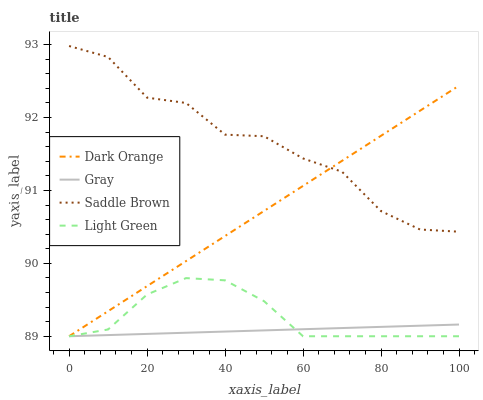Does Gray have the minimum area under the curve?
Answer yes or no. Yes. Does Saddle Brown have the maximum area under the curve?
Answer yes or no. Yes. Does Light Green have the minimum area under the curve?
Answer yes or no. No. Does Light Green have the maximum area under the curve?
Answer yes or no. No. Is Dark Orange the smoothest?
Answer yes or no. Yes. Is Saddle Brown the roughest?
Answer yes or no. Yes. Is Light Green the smoothest?
Answer yes or no. No. Is Light Green the roughest?
Answer yes or no. No. Does Saddle Brown have the lowest value?
Answer yes or no. No. Does Saddle Brown have the highest value?
Answer yes or no. Yes. Does Light Green have the highest value?
Answer yes or no. No. Is Light Green less than Saddle Brown?
Answer yes or no. Yes. Is Saddle Brown greater than Light Green?
Answer yes or no. Yes. Does Dark Orange intersect Gray?
Answer yes or no. Yes. Is Dark Orange less than Gray?
Answer yes or no. No. Is Dark Orange greater than Gray?
Answer yes or no. No. Does Light Green intersect Saddle Brown?
Answer yes or no. No. 